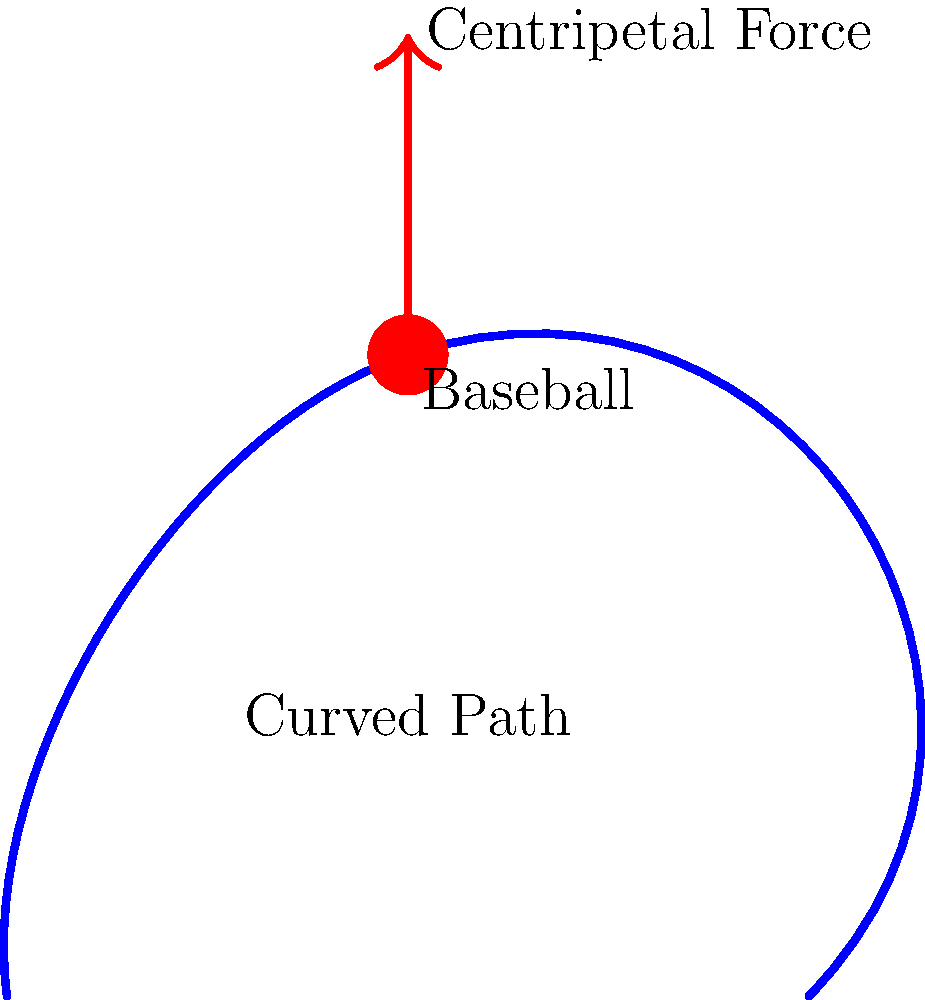During your playing days, you've thrown countless curveballs. Consider a curveball with a mass of 145 grams traveling at 40 m/s along a circular path with a radius of curvature of 20 meters at its peak curve. What is the magnitude of the centripetal force acting on the baseball at this point? Let's approach this step-by-step:

1) The formula for centripetal force is:

   $$F_c = \frac{mv^2}{r}$$

   where:
   $F_c$ is the centripetal force
   $m$ is the mass of the object
   $v$ is the velocity of the object
   $r$ is the radius of curvature

2) We're given:
   $m = 145$ g = $0.145$ kg
   $v = 40$ m/s
   $r = 20$ m

3) Let's substitute these values into our equation:

   $$F_c = \frac{0.145 \text{ kg} \times (40 \text{ m/s})^2}{20 \text{ m}}$$

4) First, let's calculate $v^2$:
   $$(40 \text{ m/s})^2 = 1600 \text{ m}^2/\text{s}^2$$

5) Now, let's plug this back into our equation:

   $$F_c = \frac{0.145 \text{ kg} \times 1600 \text{ m}^2/\text{s}^2}{20 \text{ m}}$$

6) Simplify:
   
   $$F_c = 11.6 \text{ kg} \cdot \text{m}/\text{s}^2 = 11.6 \text{ N}$$

Therefore, the magnitude of the centripetal force acting on the baseball at the peak of its curve is 11.6 N.
Answer: 11.6 N 